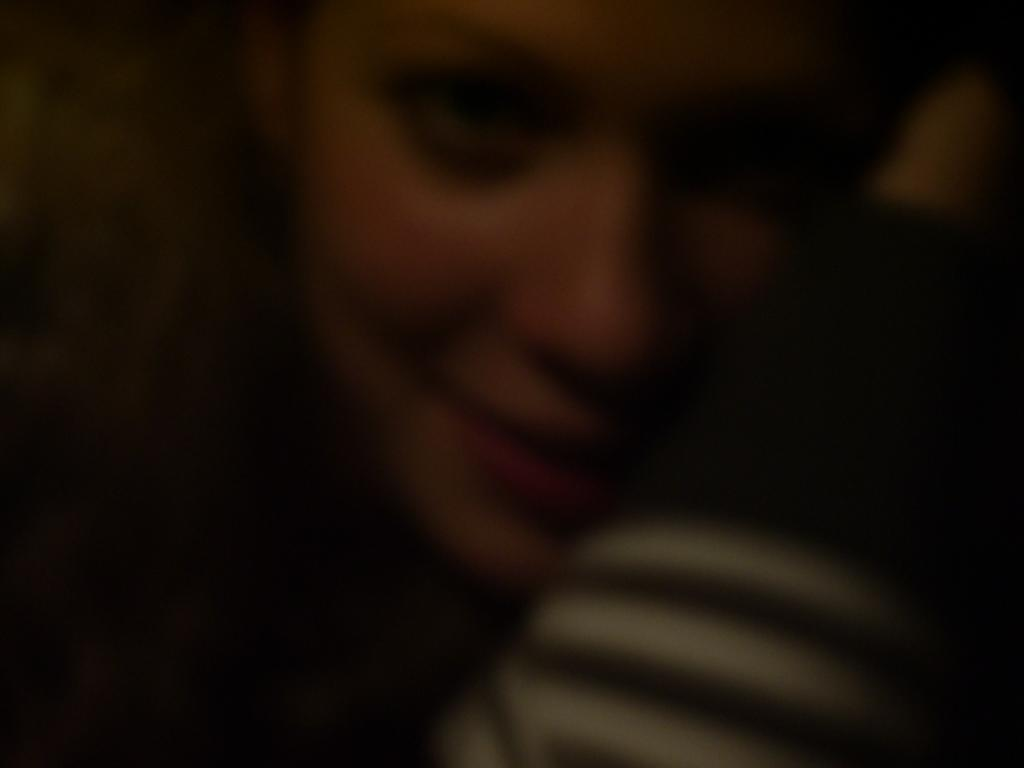What is present in the image? There is a person in the image. How is the person's expression in the image? The person is smiling. What type of knowledge is the person sharing in the image? There is no indication in the image that the person is sharing any knowledge. 